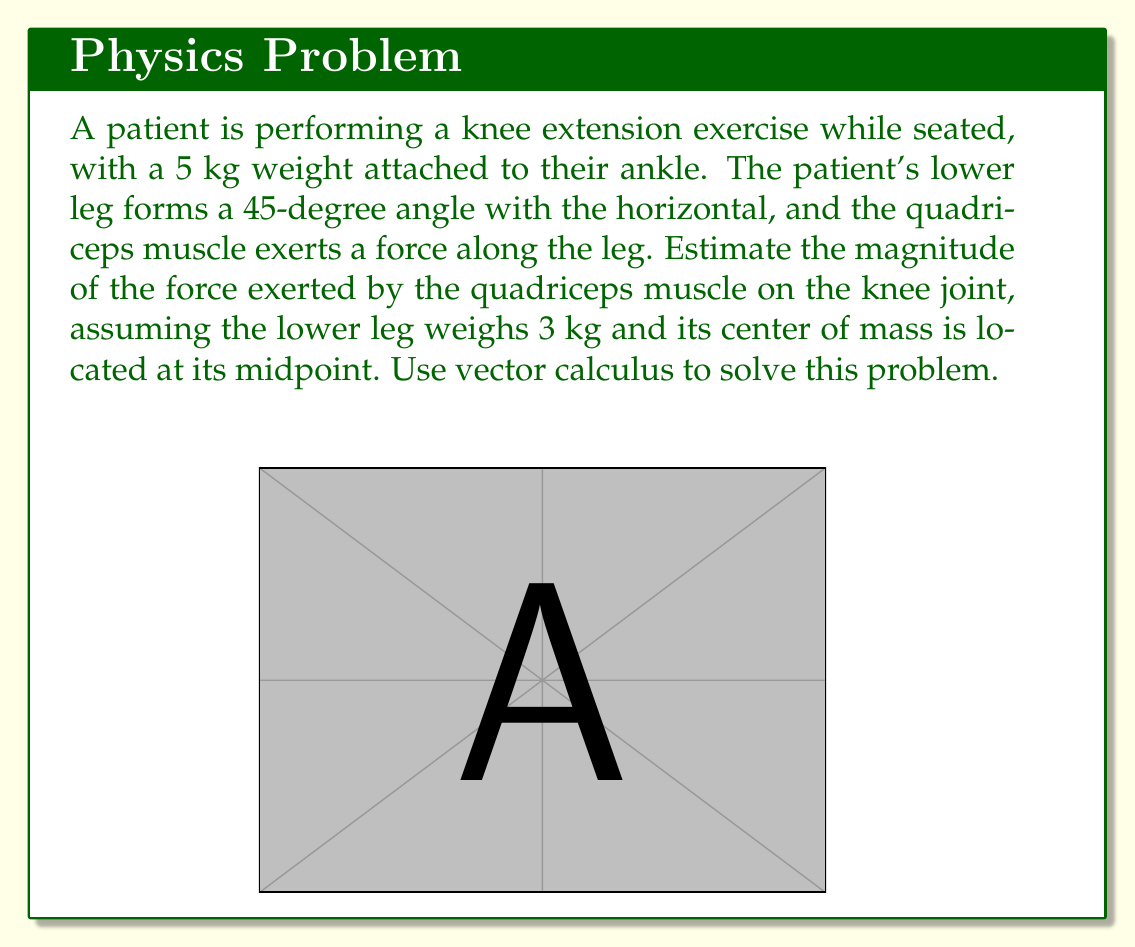Solve this math problem. To solve this problem using vector calculus, we'll follow these steps:

1) Define our coordinate system:
   Let the origin be at the knee joint, with the positive x-axis pointing horizontally and the positive y-axis pointing vertically upward.

2) Express the forces as vectors:
   - Weight of the attached weight: $\vec{W_w} = -5g\hat{j}$ N
   - Weight of the lower leg: $\vec{W_l} = -3g\hat{j}$ N
   - Force of the quadriceps: $\vec{F_q} = F_q(\cos 45°\hat{i} + \sin 45°\hat{j})$ N

   Where $g = 9.8$ m/s² is the acceleration due to gravity.

3) Apply the principle of static equilibrium. The sum of all forces and moments must be zero:

   $$\sum \vec{F} = \vec{F_q} + \vec{W_w} + \vec{W_l} = \vec{0}$$

4) Resolve this equation into x and y components:

   x-component: $F_q \cos 45° = 0$
   y-component: $F_q \sin 45° - 5g - 3g = 0$

5) Solve for $F_q$ using the y-component equation:

   $$F_q \sin 45° = 8g$$
   $$F_q = \frac{8g}{\sin 45°} = \frac{8g}{\frac{\sqrt{2}}{2}} = 8g\sqrt{2}$$

6) Calculate the numerical value:

   $$F_q = 8 \cdot 9.8 \cdot \sqrt{2} \approx 110.85 \text{ N}$$

Therefore, the magnitude of the force exerted by the quadriceps muscle on the knee joint is approximately 110.85 N.
Answer: The magnitude of the force exerted by the quadriceps muscle on the knee joint is approximately 110.85 N. 